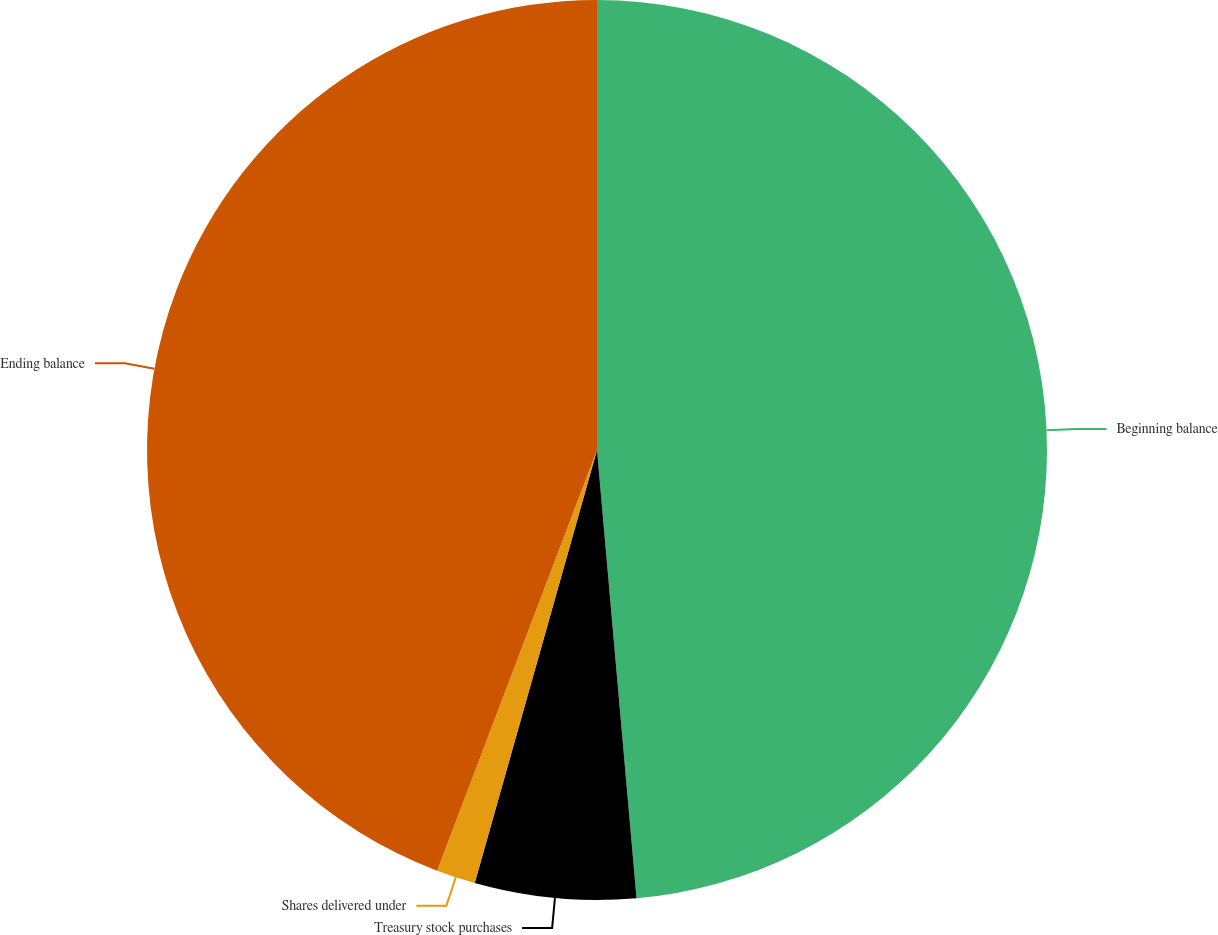<chart> <loc_0><loc_0><loc_500><loc_500><pie_chart><fcel>Beginning balance<fcel>Treasury stock purchases<fcel>Shares delivered under<fcel>Ending balance<nl><fcel>48.6%<fcel>5.78%<fcel>1.4%<fcel>44.22%<nl></chart> 